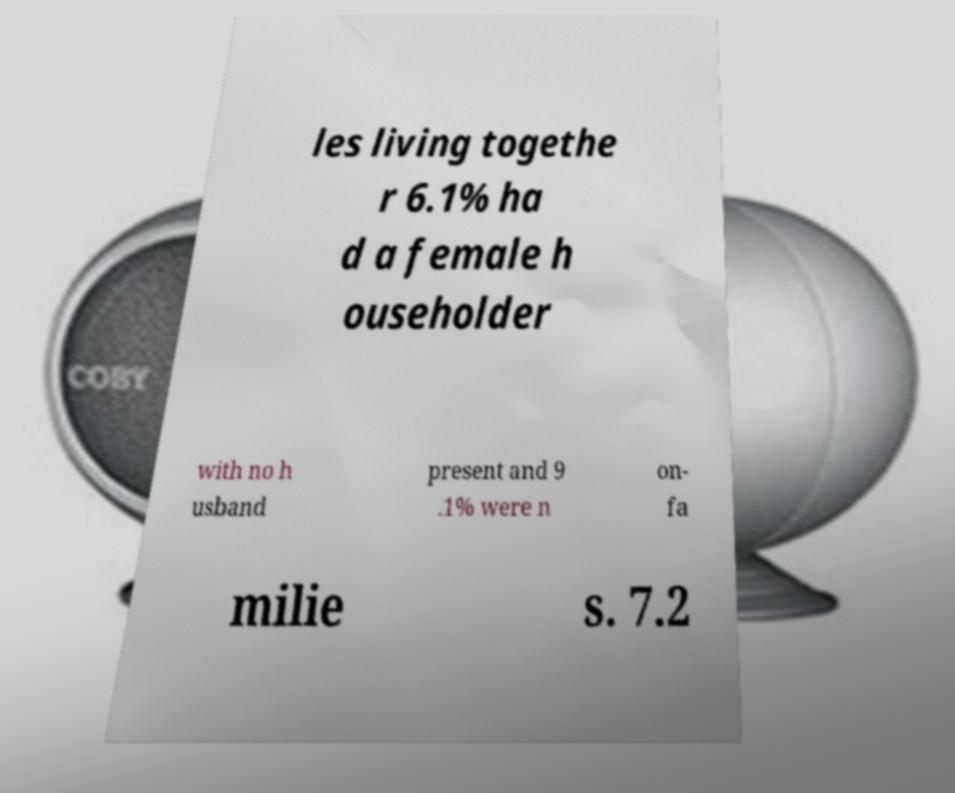Please identify and transcribe the text found in this image. les living togethe r 6.1% ha d a female h ouseholder with no h usband present and 9 .1% were n on- fa milie s. 7.2 